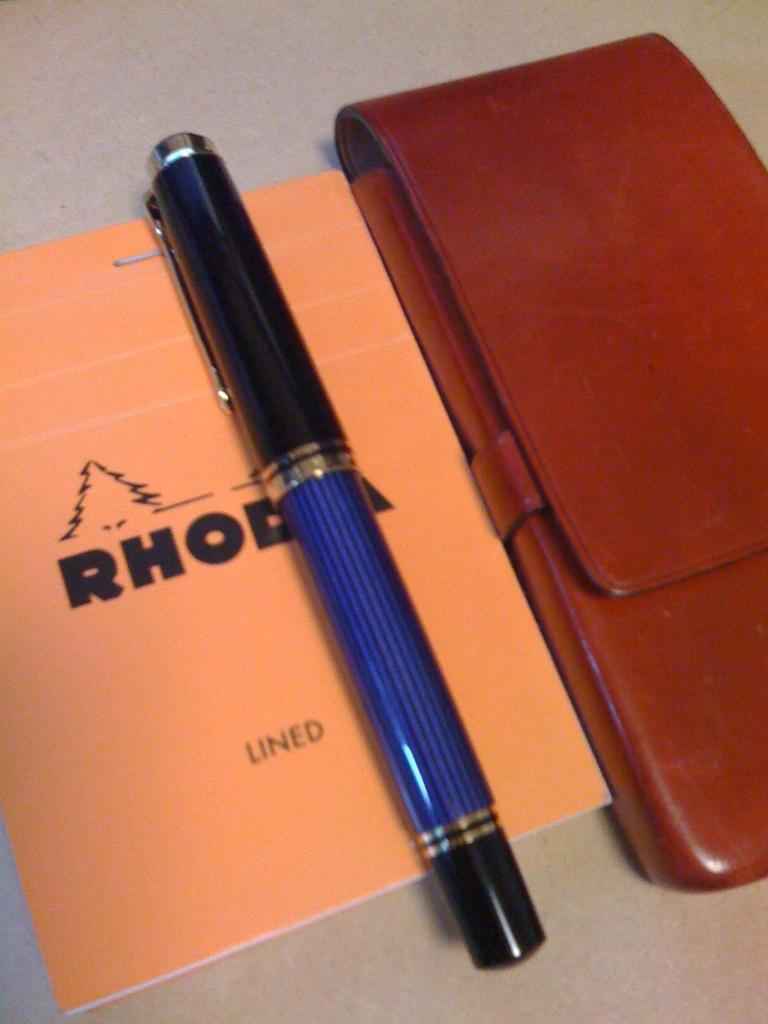Please provide a concise description of this image. In this image, we can see a book, a pen and an object on the surface. 